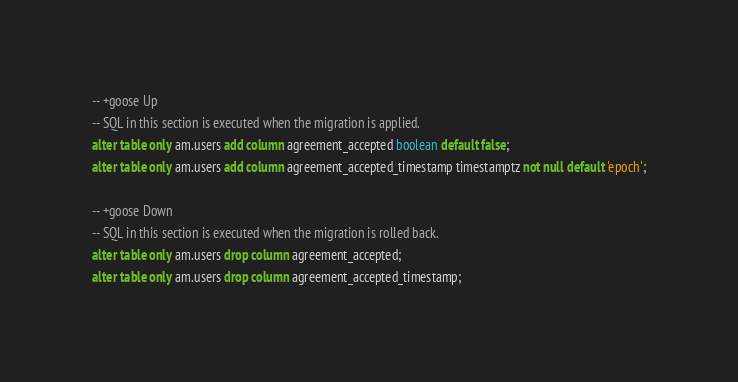<code> <loc_0><loc_0><loc_500><loc_500><_SQL_>-- +goose Up
-- SQL in this section is executed when the migration is applied.
alter table only am.users add column agreement_accepted boolean default false;
alter table only am.users add column agreement_accepted_timestamp timestamptz not null default 'epoch';

-- +goose Down
-- SQL in this section is executed when the migration is rolled back.
alter table only am.users drop column agreement_accepted;
alter table only am.users drop column agreement_accepted_timestamp;
</code> 